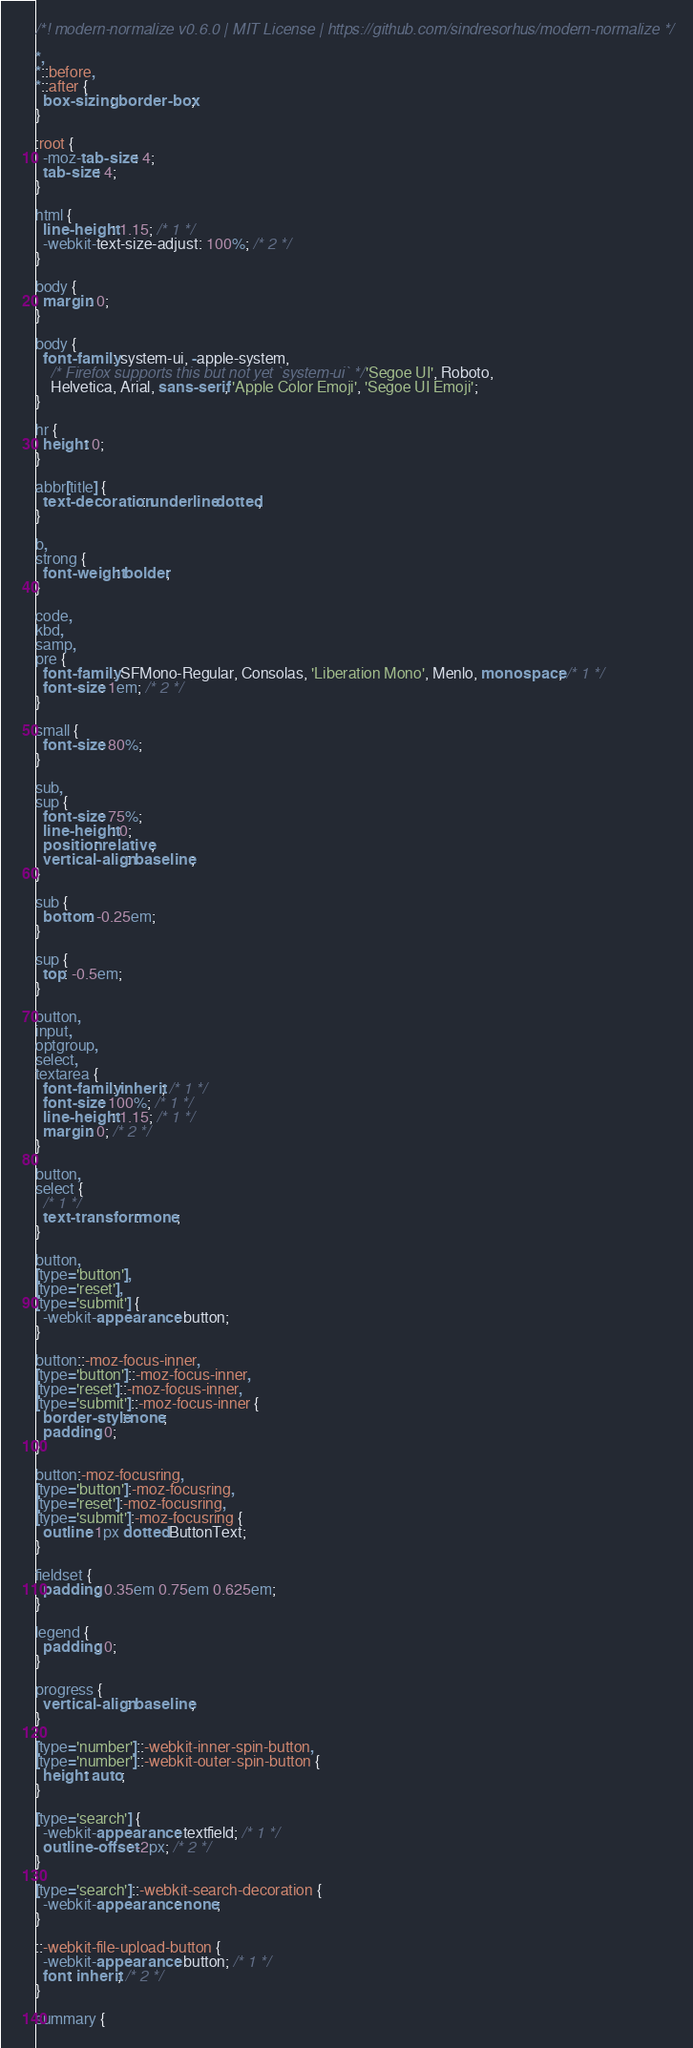Convert code to text. <code><loc_0><loc_0><loc_500><loc_500><_CSS_>/*! modern-normalize v0.6.0 | MIT License | https://github.com/sindresorhus/modern-normalize */

*,
*::before,
*::after {
  box-sizing: border-box;
}

:root {
  -moz-tab-size: 4;
  tab-size: 4;
}

html {
  line-height: 1.15; /* 1 */
  -webkit-text-size-adjust: 100%; /* 2 */
}

body {
  margin: 0;
}

body {
  font-family: system-ui, -apple-system,
    /* Firefox supports this but not yet `system-ui` */ 'Segoe UI', Roboto,
    Helvetica, Arial, sans-serif, 'Apple Color Emoji', 'Segoe UI Emoji';
}

hr {
  height: 0;
}

abbr[title] {
  text-decoration: underline dotted;
}

b,
strong {
  font-weight: bolder;
}

code,
kbd,
samp,
pre {
  font-family: SFMono-Regular, Consolas, 'Liberation Mono', Menlo, monospace; /* 1 */
  font-size: 1em; /* 2 */
}

small {
  font-size: 80%;
}

sub,
sup {
  font-size: 75%;
  line-height: 0;
  position: relative;
  vertical-align: baseline;
}

sub {
  bottom: -0.25em;
}

sup {
  top: -0.5em;
}

button,
input,
optgroup,
select,
textarea {
  font-family: inherit; /* 1 */
  font-size: 100%; /* 1 */
  line-height: 1.15; /* 1 */
  margin: 0; /* 2 */
}

button,
select {
  /* 1 */
  text-transform: none;
}

button,
[type='button'],
[type='reset'],
[type='submit'] {
  -webkit-appearance: button;
}

button::-moz-focus-inner,
[type='button']::-moz-focus-inner,
[type='reset']::-moz-focus-inner,
[type='submit']::-moz-focus-inner {
  border-style: none;
  padding: 0;
}

button:-moz-focusring,
[type='button']:-moz-focusring,
[type='reset']:-moz-focusring,
[type='submit']:-moz-focusring {
  outline: 1px dotted ButtonText;
}

fieldset {
  padding: 0.35em 0.75em 0.625em;
}

legend {
  padding: 0;
}

progress {
  vertical-align: baseline;
}

[type='number']::-webkit-inner-spin-button,
[type='number']::-webkit-outer-spin-button {
  height: auto;
}

[type='search'] {
  -webkit-appearance: textfield; /* 1 */
  outline-offset: -2px; /* 2 */
}

[type='search']::-webkit-search-decoration {
  -webkit-appearance: none;
}

::-webkit-file-upload-button {
  -webkit-appearance: button; /* 1 */
  font: inherit; /* 2 */
}

summary {</code> 